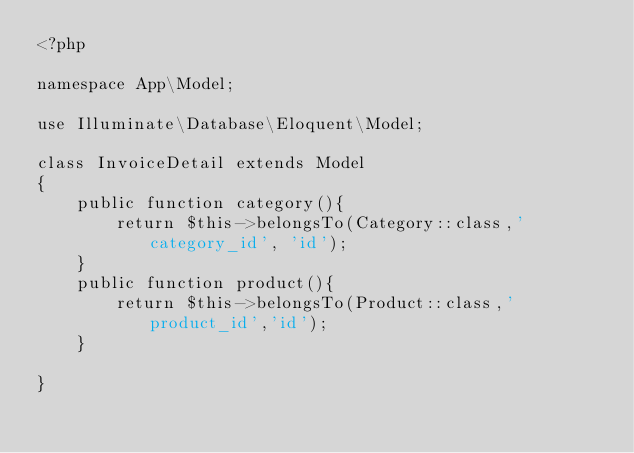<code> <loc_0><loc_0><loc_500><loc_500><_PHP_><?php

namespace App\Model;

use Illuminate\Database\Eloquent\Model;

class InvoiceDetail extends Model
{
    public function category(){
        return $this->belongsTo(Category::class,'category_id', 'id');
    }
    public function product(){
        return $this->belongsTo(Product::class,'product_id','id');
    }

}
</code> 